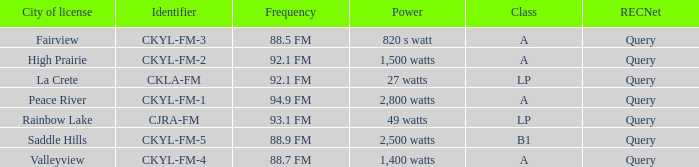What frequency corresponds to a city of license in fairview? 88.5 FM. 